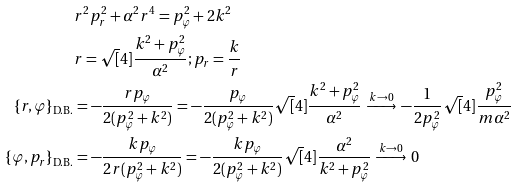<formula> <loc_0><loc_0><loc_500><loc_500>& r ^ { 2 } p _ { r } ^ { 2 } + \alpha ^ { 2 } r ^ { 4 } = p _ { \varphi } ^ { 2 } + 2 k ^ { 2 } \\ & r = \sqrt { [ } 4 ] { \frac { k ^ { 2 } + p _ { \varphi } ^ { 2 } } { \alpha ^ { 2 } } } ; p _ { r } = \frac { k } { r } \\ \{ r , \varphi \} _ { \text {D.B.} } & = - \frac { r p _ { \varphi } } { 2 ( p _ { \varphi } ^ { 2 } + k ^ { 2 } ) } = - \frac { p _ { \varphi } } { 2 ( p _ { \varphi } ^ { 2 } + k ^ { 2 } ) } \sqrt { [ } 4 ] { \frac { k ^ { 2 } + p _ { \varphi } ^ { 2 } } { \alpha ^ { 2 } } } \, \xrightarrow { k \rightarrow 0 } \, - \frac { 1 } { 2 p _ { \varphi } ^ { 2 } } \sqrt { [ } 4 ] { \frac { p _ { \varphi } ^ { 2 } } { m \alpha ^ { 2 } } } \\ \{ \varphi , p _ { r } \} _ { \text {D.B.} } & = - \frac { k p _ { \varphi } } { 2 r ( p _ { \varphi } ^ { 2 } + k ^ { 2 } ) } = - \frac { k p _ { \varphi } } { 2 ( p _ { \varphi } ^ { 2 } + k ^ { 2 } ) } \sqrt { [ } 4 ] { \frac { \alpha ^ { 2 } } { k ^ { 2 } + p _ { \varphi } ^ { 2 } } } \, \xrightarrow { k \rightarrow 0 } \, 0</formula> 